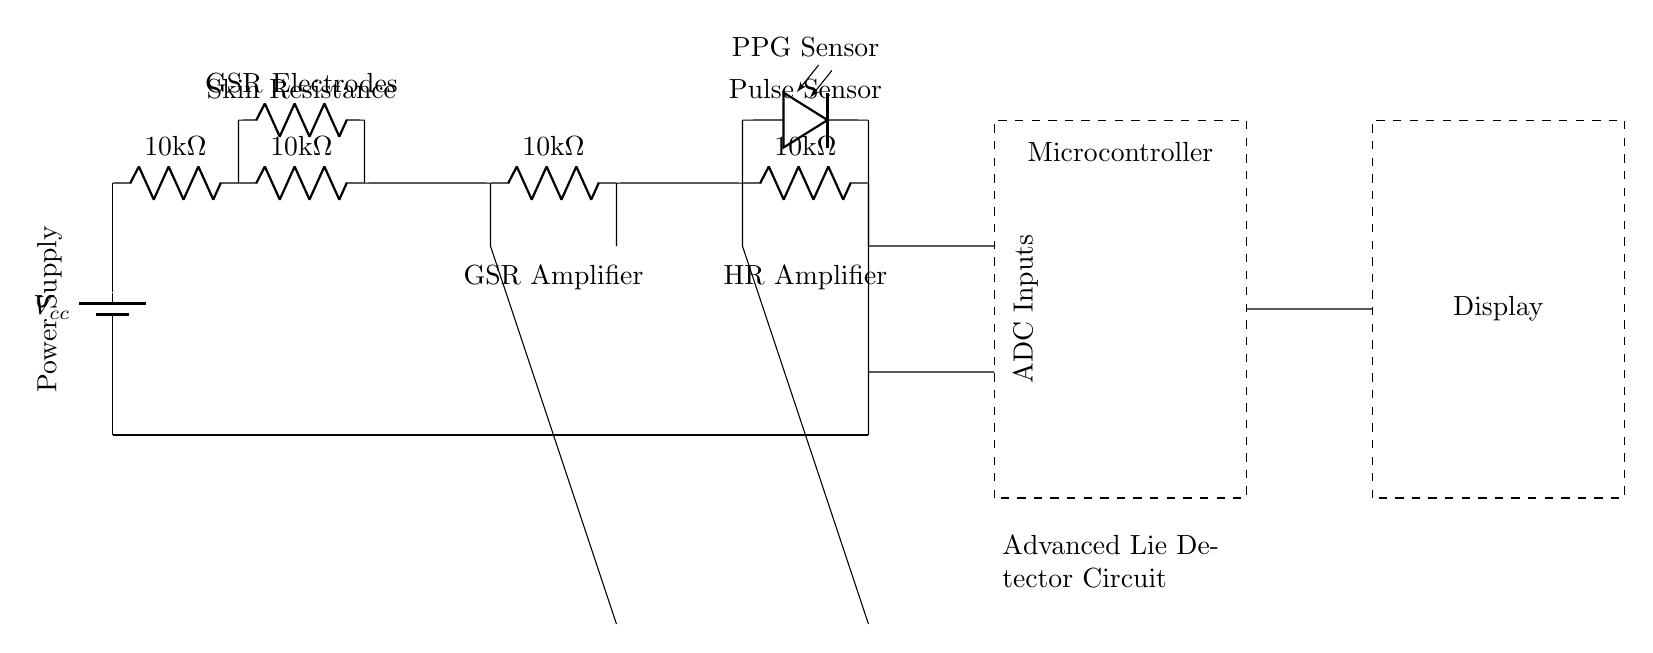What type of sensor is used to measure heart rate? The diagram indicates that a photodiode is employed for this purpose, as labeled "PPG Sensor."
Answer: Photodiode What is the total resistance of the resistors in the GSR section? There are four resistors in series, each with a value of 10k ohms. Therefore, total resistance is 10k plus 10k plus 10k plus 10k, which equals 40k ohms.
Answer: 40k ohms What component amplifies the skin resistance signal? The circuit includes an operational amplifier (op amp) designated as the GSR Amplifier, which amplifies the skin resistance measurements.
Answer: Op amp How many ADC inputs are connected to the microcontroller? The connections show that there are two inputs from the GSR and heart rate analysis sections leading to the microcontroller's ADC inputs.
Answer: Two What is the power supply voltage indicated? The circuit specifies a battery with a label "Vcc," which generally indicates the supply voltage; however, the exact voltage value is not provided in the diagram. It's usually assumed to be a standard voltage, like 5 volts.
Answer: Vcc What is the function of the components labeled "GSR Electrodes"? These components are the sensors that measure the galvanic skin response by detecting skin conductivity, which changes with emotional states.
Answer: Measure skin conductivity What is displayed as the output from the microcontroller? The figure notes a "Display," which implies that the processed data from both sensors will be shown on this output device for analysis.
Answer: Display 